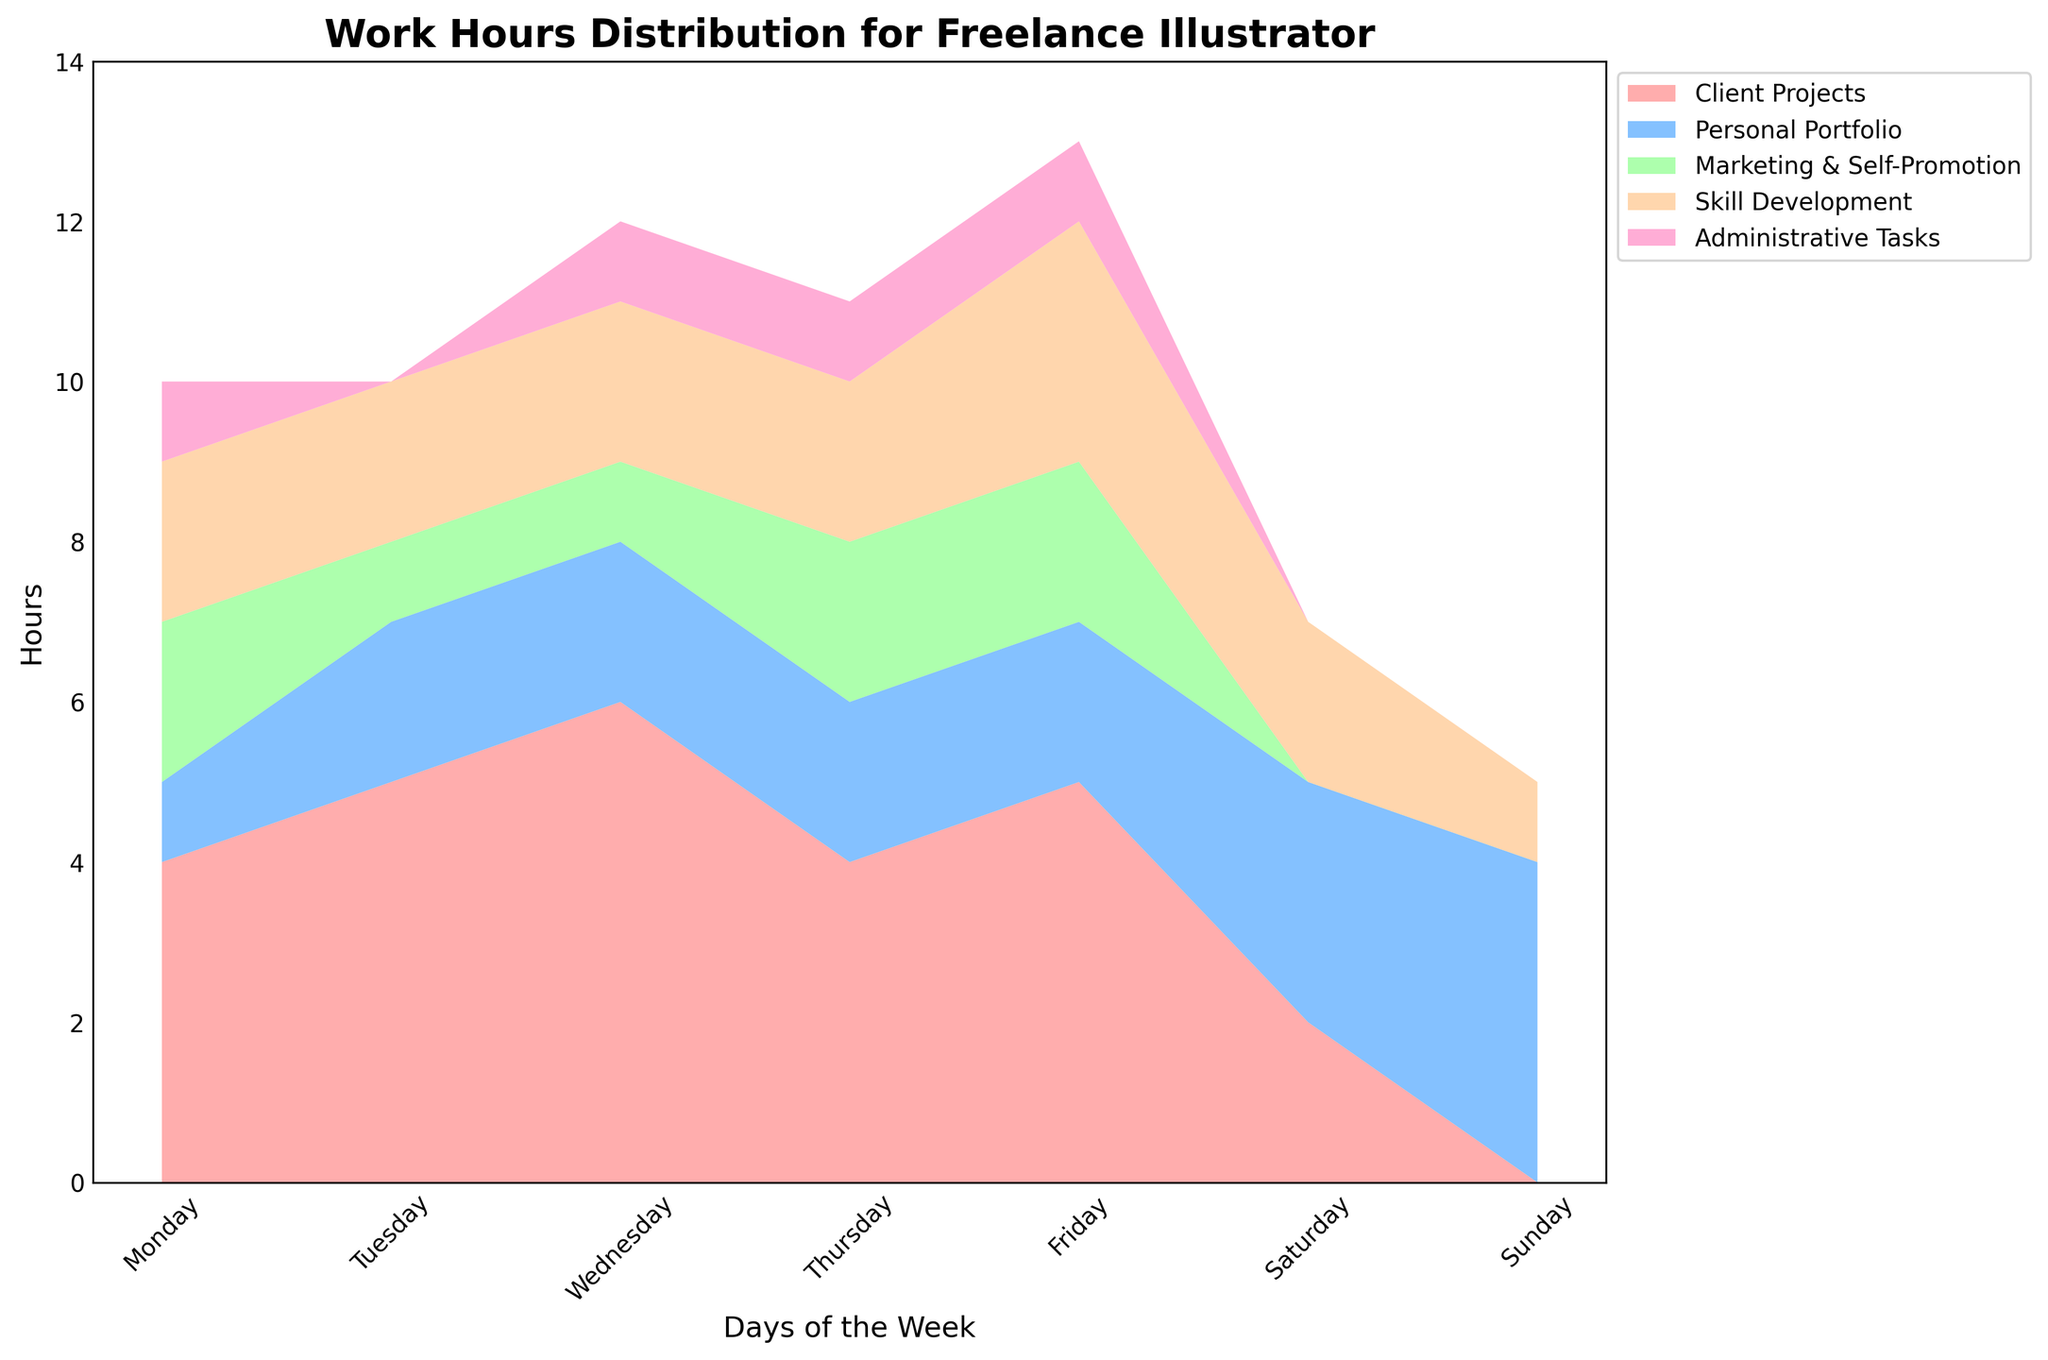What is the title of the chart? The title of the chart is usually displayed at the top of the plot. In this case, it reads "Work Hours Distribution for Freelance Illustrator."
Answer: Work Hours Distribution for Freelance Illustrator What is the total number of work hours on Monday? To find the total number of work hours on Monday, add the hours spent on each task: 4 (Client Projects) + 1 (Personal Portfolio) + 2 (Marketing & Self-Promotion) + 2 (Skill Development) + 1 (Administrative Tasks) = 10 hours.
Answer: 10 hours Which day has the highest total number of work hours? Sum the hours for each day: Monday (10), Tuesday (10), Wednesday (12), Thursday (11), Friday (13), Saturday (7), Sunday (5). The highest number is 13 on Friday.
Answer: Friday On which day is the least amount of time spent on Administrative Tasks? According to the chart, Administrative Tasks have 0 hours on Tuesday, Saturday, and Sunday. Since 0 is the least amount, the days are Tuesday, Saturday, and Sunday.
Answer: Tuesday, Saturday, and Sunday How many more hours does the illustrator spend on Client Projects on Wednesday compared to Saturday? Client Projects on Wednesday is 6 hours, and on Saturday is 2 hours. The difference is 6 - 2 = 4 hours.
Answer: 4 hours What is the average number of hours spent on Skill Development from Monday to Sunday? Sum the hours spent on Skill Development across all days: 2 + 2 + 2 + 2 + 3 + 2 + 1 = 14. To get the average: 14/7 = 2 hours.
Answer: 2 hours Which task sees the highest amount of increase from the start of the week to the end? By examining the trends for each task from Monday to Sunday: Client Projects (4 to 0, decrease), Personal Portfolio (1 to 4, increase of 3), Marketing & Self-Promotion (2 to 0, decrease), Skill Development (2 to 1, decrease), Administrative Tasks (1 to 0, decrease). Personal Portfolio shows the highest increase (3 hours).
Answer: Personal Portfolio Between Marketing & Self-Promotion and Administrative Tasks, which task has the highest total hours over the week? Sum the hours for each task: Marketing & Self-Promotion: 2+1+1+2+2+0+0=8, Administrative Tasks: 1+0+1+1+1+0+0=4. Marketing & Self-Promotion has the highest total hours.
Answer: Marketing & Self-Promotion What is the range of hours spent on Client Projects over the week? Find the maximum and minimum values for Client Projects: Max (6 hours on Wednesday), Min (0 hours on Sunday). The range is 6 - 0 = 6 hours.
Answer: 6 hours On which day is the illustrator's workload distributed among the fewest number of tasks? Count the number of tasks with more than 0 hours each day: Monday (5), Tuesday (4), Wednesday (5), Thursday (5), Friday (5), Saturday (3), Sunday (3). The fewest are on Saturday and Sunday.
Answer: Saturday and Sunday 